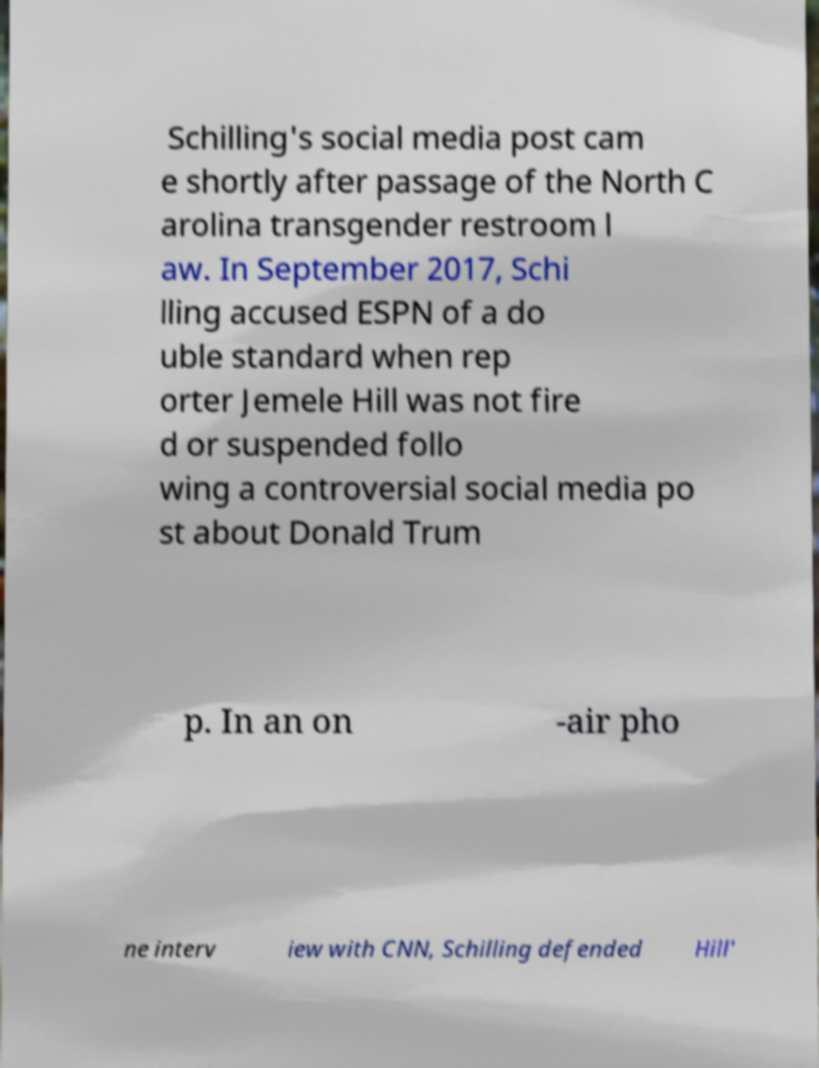What messages or text are displayed in this image? I need them in a readable, typed format. Schilling's social media post cam e shortly after passage of the North C arolina transgender restroom l aw. In September 2017, Schi lling accused ESPN of a do uble standard when rep orter Jemele Hill was not fire d or suspended follo wing a controversial social media po st about Donald Trum p. In an on -air pho ne interv iew with CNN, Schilling defended Hill' 